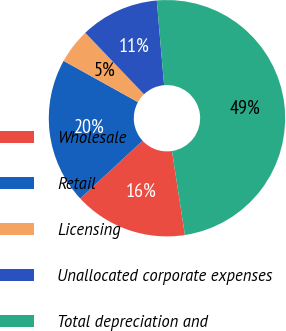<chart> <loc_0><loc_0><loc_500><loc_500><pie_chart><fcel>Wholesale<fcel>Retail<fcel>Licensing<fcel>Unallocated corporate expenses<fcel>Total depreciation and<nl><fcel>15.54%<fcel>19.95%<fcel>4.79%<fcel>10.77%<fcel>48.95%<nl></chart> 